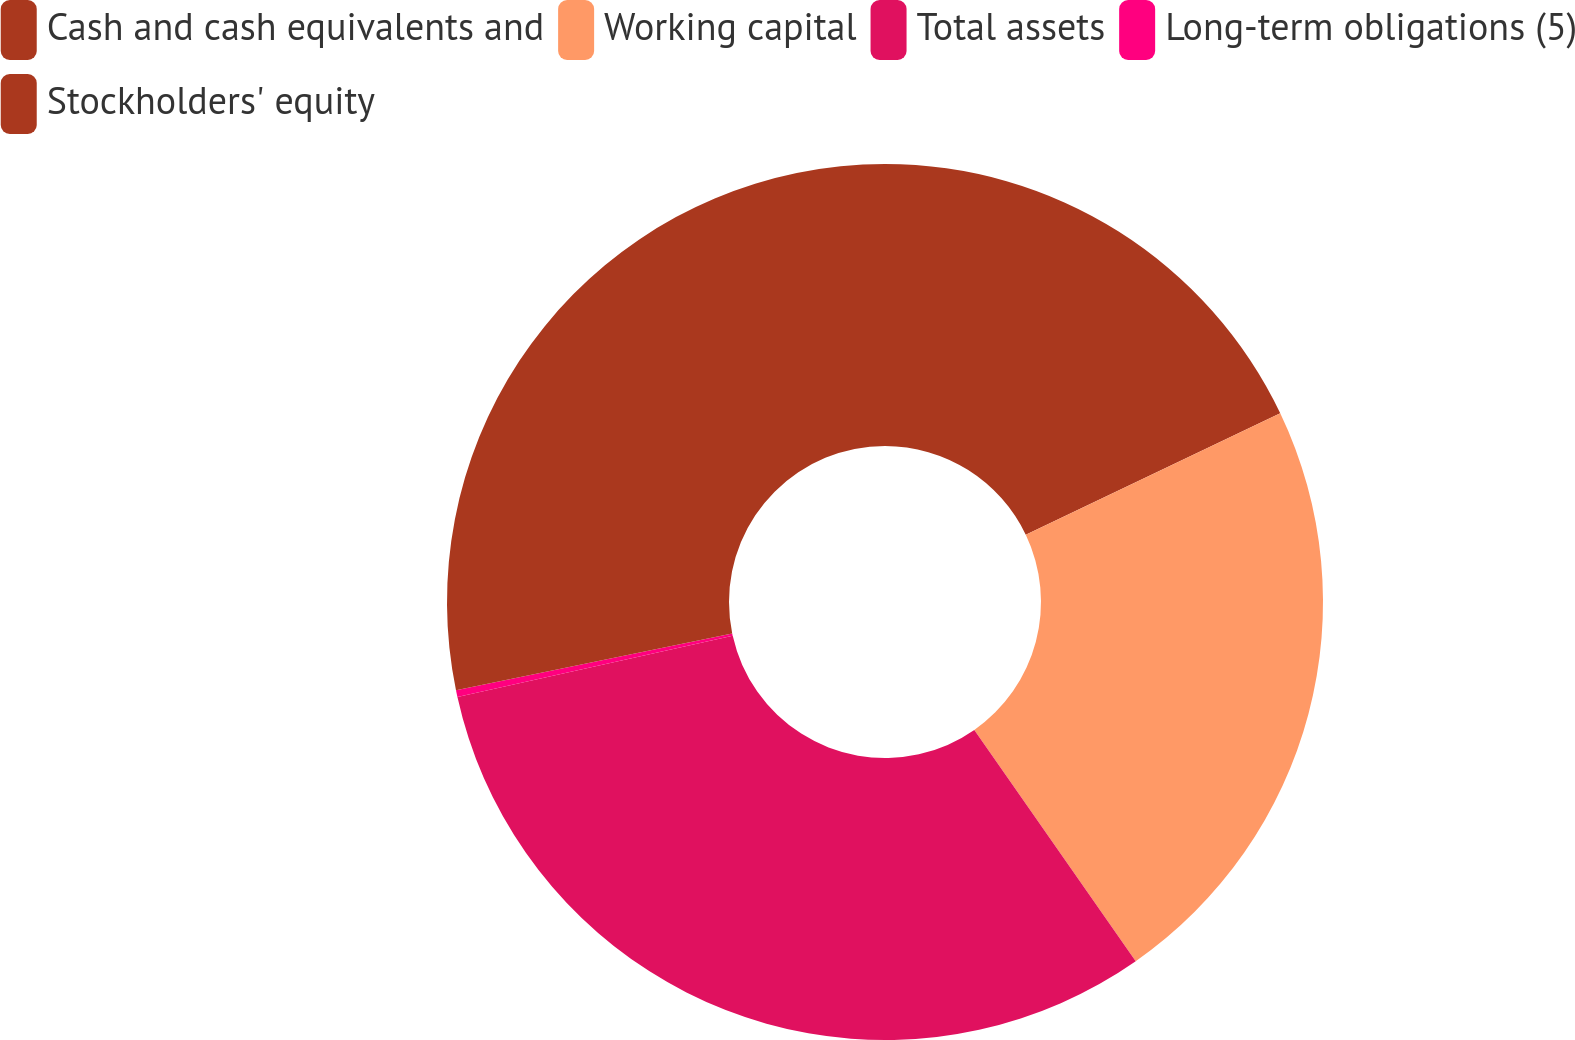Convert chart to OTSL. <chart><loc_0><loc_0><loc_500><loc_500><pie_chart><fcel>Cash and cash equivalents and<fcel>Working capital<fcel>Total assets<fcel>Long-term obligations (5)<fcel>Stockholders' equity<nl><fcel>17.91%<fcel>22.39%<fcel>31.22%<fcel>0.25%<fcel>28.23%<nl></chart> 